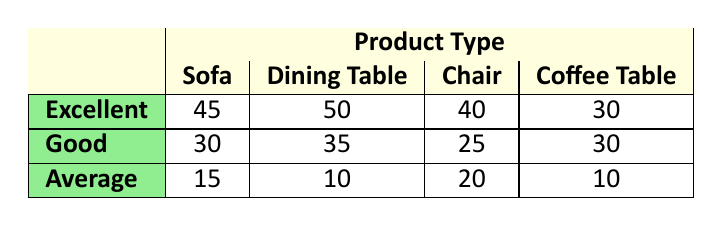What is the count of customers who rated the Chair as 'Excellent'? The table shows that for the Chair product type, under the Excellent experience, the count is 40.
Answer: 40 What is the highest customer satisfaction rating for the Dining Table? According to the table, the Dining Table has the highest rating of 50 customers giving an Excellent experience.
Answer: 50 How many customers rated the Sofa as 'Average'? The count for customers who rated the Sofa as Average can be found in the table, which indicates there are 15 customers.
Answer: 15 Which product type has the lowest overall satisfaction count across all experience levels? To find the lowest overall satisfaction, we sum the counts for each product: Sofa (90), Dining Table (95), Chair (85), Coffee Table (70). The Coffee Table has the lowest total with 70.
Answer: Coffee Table Is it true that more customers rated the Sofa as 'Good' than those who rated the Coffee Table as 'Excellent'? The count for Sofa rated as Good is 30, while the count for Coffee Table rated as Excellent is 30. Since they are equal, this statement is false.
Answer: No 